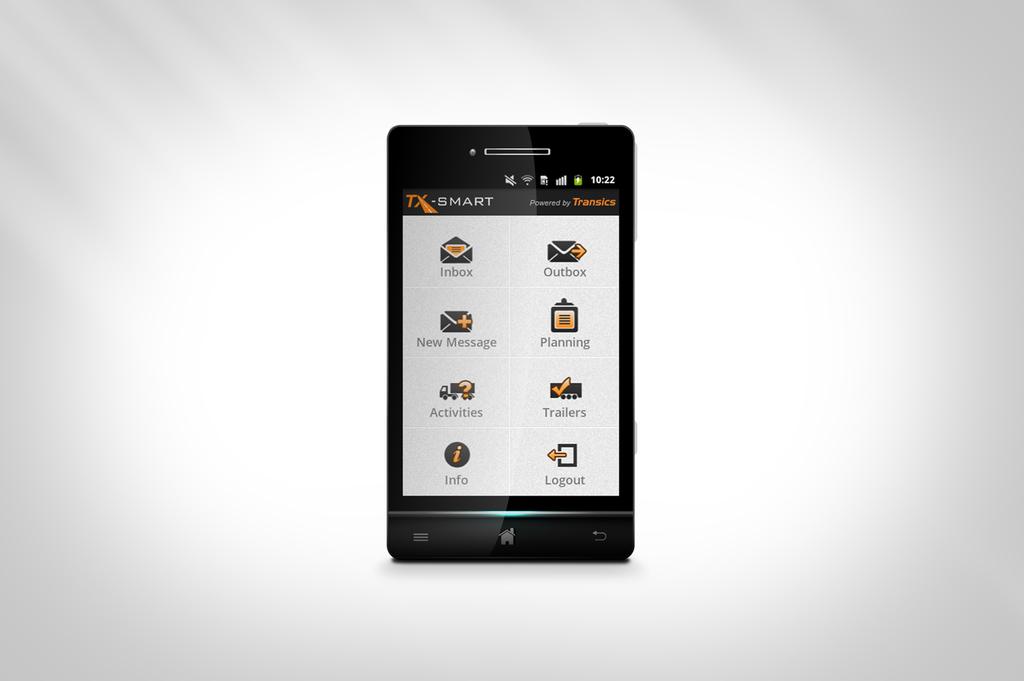Who makes this phone?
Your response must be concise. Transics. What does it say under the bottom right icon?
Ensure brevity in your answer.  Logout. 